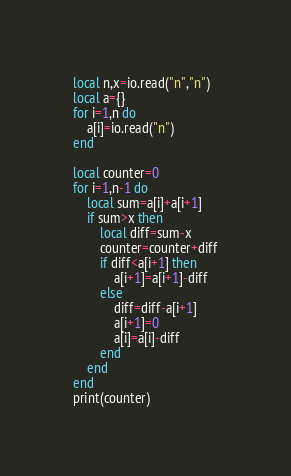<code> <loc_0><loc_0><loc_500><loc_500><_Lua_>local n,x=io.read("n","n")
local a={}
for i=1,n do
    a[i]=io.read("n")
end

local counter=0
for i=1,n-1 do
    local sum=a[i]+a[i+1]
    if sum>x then
        local diff=sum-x
        counter=counter+diff
        if diff<a[i+1] then
            a[i+1]=a[i+1]-diff
        else
            diff=diff-a[i+1]
            a[i+1]=0
            a[i]=a[i]-diff
        end
    end
end
print(counter)</code> 